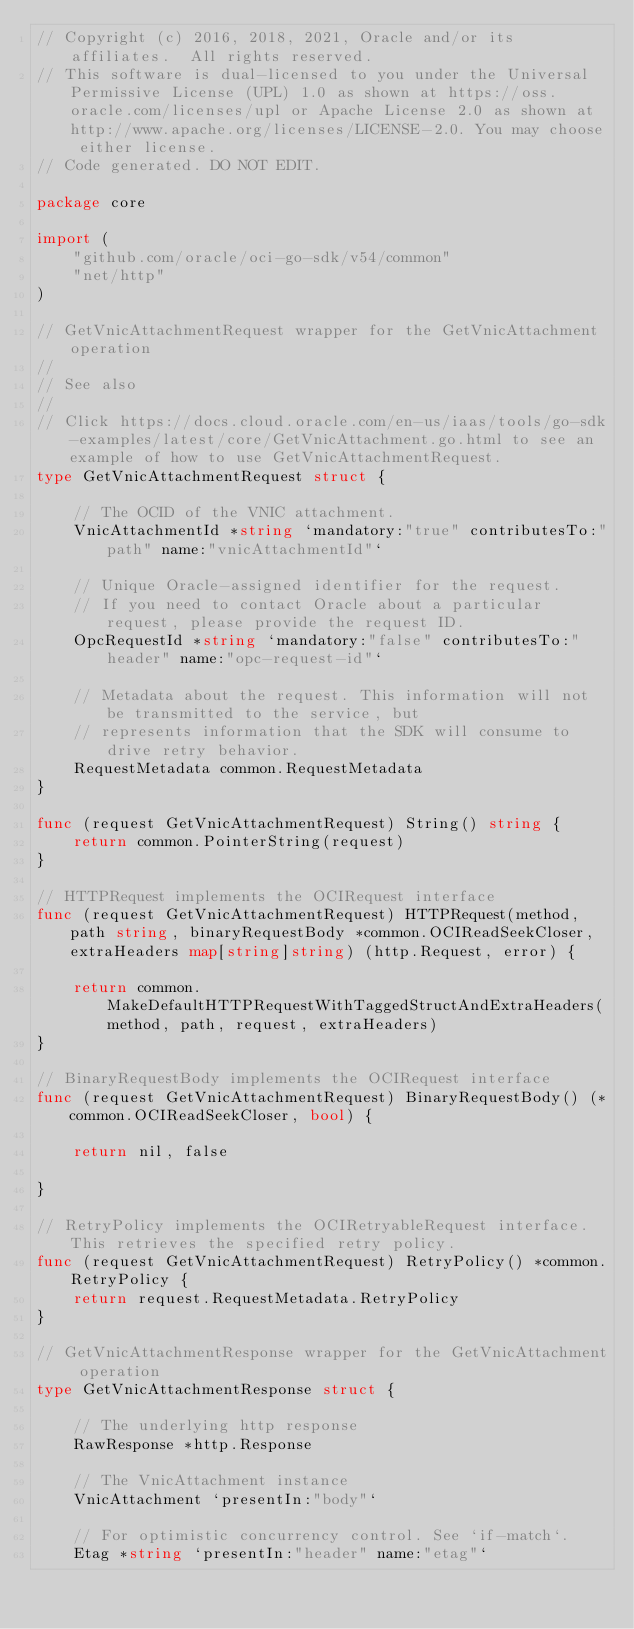Convert code to text. <code><loc_0><loc_0><loc_500><loc_500><_Go_>// Copyright (c) 2016, 2018, 2021, Oracle and/or its affiliates.  All rights reserved.
// This software is dual-licensed to you under the Universal Permissive License (UPL) 1.0 as shown at https://oss.oracle.com/licenses/upl or Apache License 2.0 as shown at http://www.apache.org/licenses/LICENSE-2.0. You may choose either license.
// Code generated. DO NOT EDIT.

package core

import (
	"github.com/oracle/oci-go-sdk/v54/common"
	"net/http"
)

// GetVnicAttachmentRequest wrapper for the GetVnicAttachment operation
//
// See also
//
// Click https://docs.cloud.oracle.com/en-us/iaas/tools/go-sdk-examples/latest/core/GetVnicAttachment.go.html to see an example of how to use GetVnicAttachmentRequest.
type GetVnicAttachmentRequest struct {

	// The OCID of the VNIC attachment.
	VnicAttachmentId *string `mandatory:"true" contributesTo:"path" name:"vnicAttachmentId"`

	// Unique Oracle-assigned identifier for the request.
	// If you need to contact Oracle about a particular request, please provide the request ID.
	OpcRequestId *string `mandatory:"false" contributesTo:"header" name:"opc-request-id"`

	// Metadata about the request. This information will not be transmitted to the service, but
	// represents information that the SDK will consume to drive retry behavior.
	RequestMetadata common.RequestMetadata
}

func (request GetVnicAttachmentRequest) String() string {
	return common.PointerString(request)
}

// HTTPRequest implements the OCIRequest interface
func (request GetVnicAttachmentRequest) HTTPRequest(method, path string, binaryRequestBody *common.OCIReadSeekCloser, extraHeaders map[string]string) (http.Request, error) {

	return common.MakeDefaultHTTPRequestWithTaggedStructAndExtraHeaders(method, path, request, extraHeaders)
}

// BinaryRequestBody implements the OCIRequest interface
func (request GetVnicAttachmentRequest) BinaryRequestBody() (*common.OCIReadSeekCloser, bool) {

	return nil, false

}

// RetryPolicy implements the OCIRetryableRequest interface. This retrieves the specified retry policy.
func (request GetVnicAttachmentRequest) RetryPolicy() *common.RetryPolicy {
	return request.RequestMetadata.RetryPolicy
}

// GetVnicAttachmentResponse wrapper for the GetVnicAttachment operation
type GetVnicAttachmentResponse struct {

	// The underlying http response
	RawResponse *http.Response

	// The VnicAttachment instance
	VnicAttachment `presentIn:"body"`

	// For optimistic concurrency control. See `if-match`.
	Etag *string `presentIn:"header" name:"etag"`
</code> 